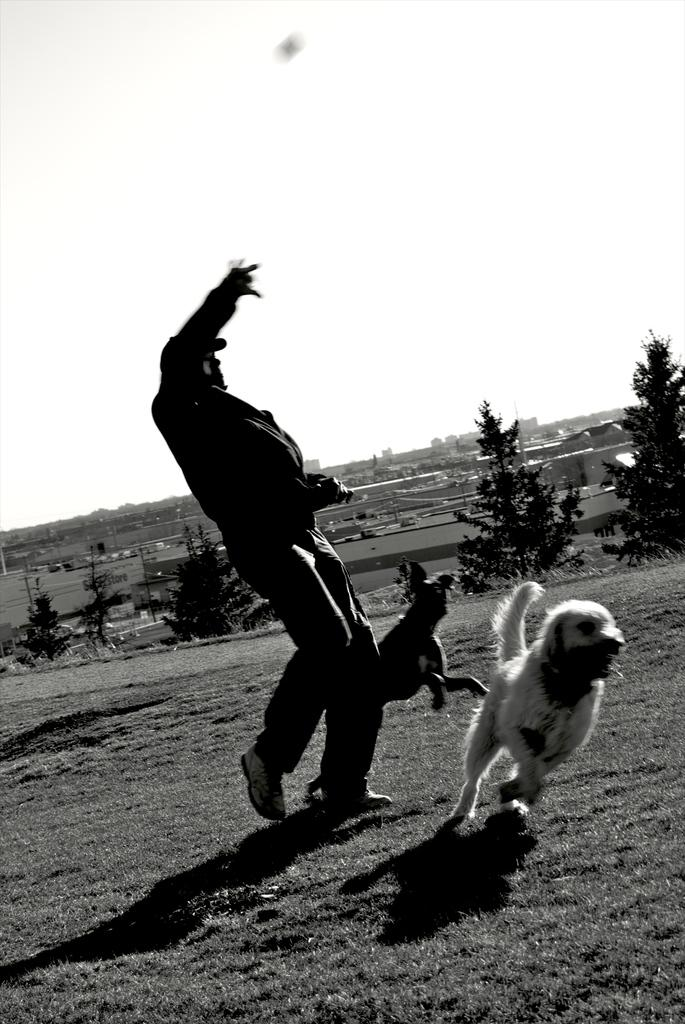What is the color scheme of the image? The image is black and white. What can be seen in the background of the image? There are trees in the background of the image. Who or what is present in the image? There is a man and a dog in the image. What type of feast is being prepared in the image? There is no indication of a feast or any food preparation in the image. Is there a volleyball game happening in the image? There is no volleyball game or any sports activity depicted in the image. 